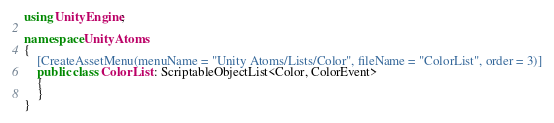Convert code to text. <code><loc_0><loc_0><loc_500><loc_500><_C#_>using UnityEngine;

namespace UnityAtoms
{
    [CreateAssetMenu(menuName = "Unity Atoms/Lists/Color", fileName = "ColorList", order = 3)]
    public class ColorList : ScriptableObjectList<Color, ColorEvent>
    {
    }
}</code> 